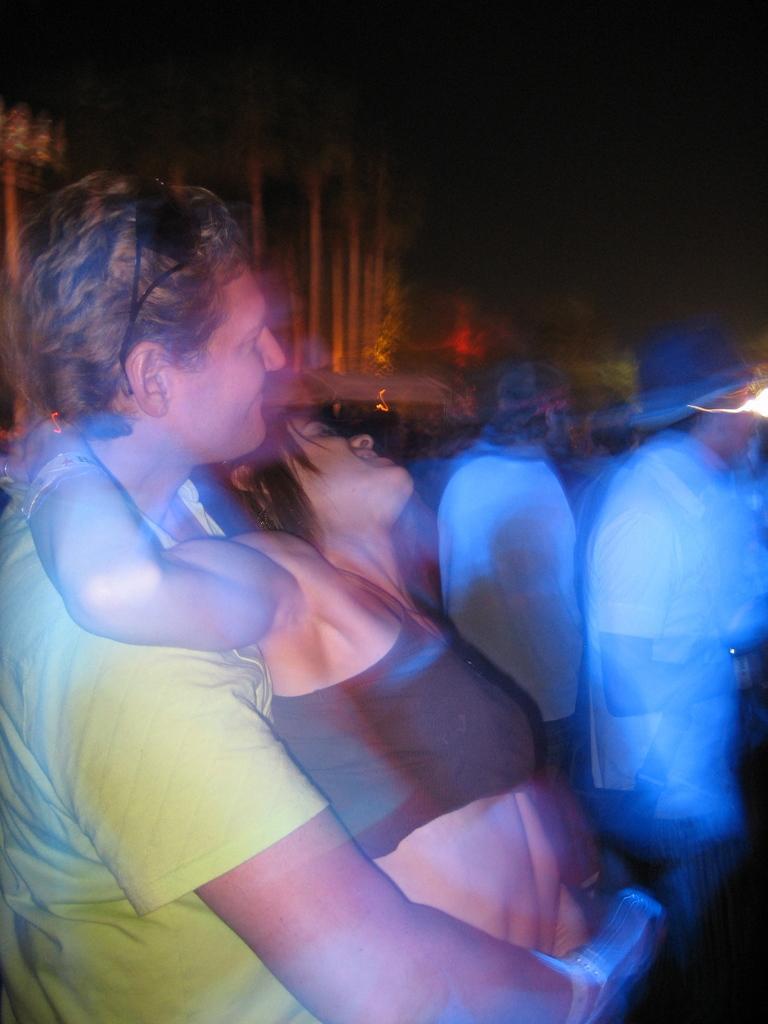How would you summarize this image in a sentence or two? In this image we can see a man and a lady standing. In the background there are lights and we can see people. 